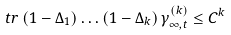Convert formula to latex. <formula><loc_0><loc_0><loc_500><loc_500>\ t r \, ( 1 - \Delta _ { 1 } ) \dots ( 1 - \Delta _ { k } ) \, \gamma ^ { ( k ) } _ { \infty , t } \leq C ^ { k }</formula> 